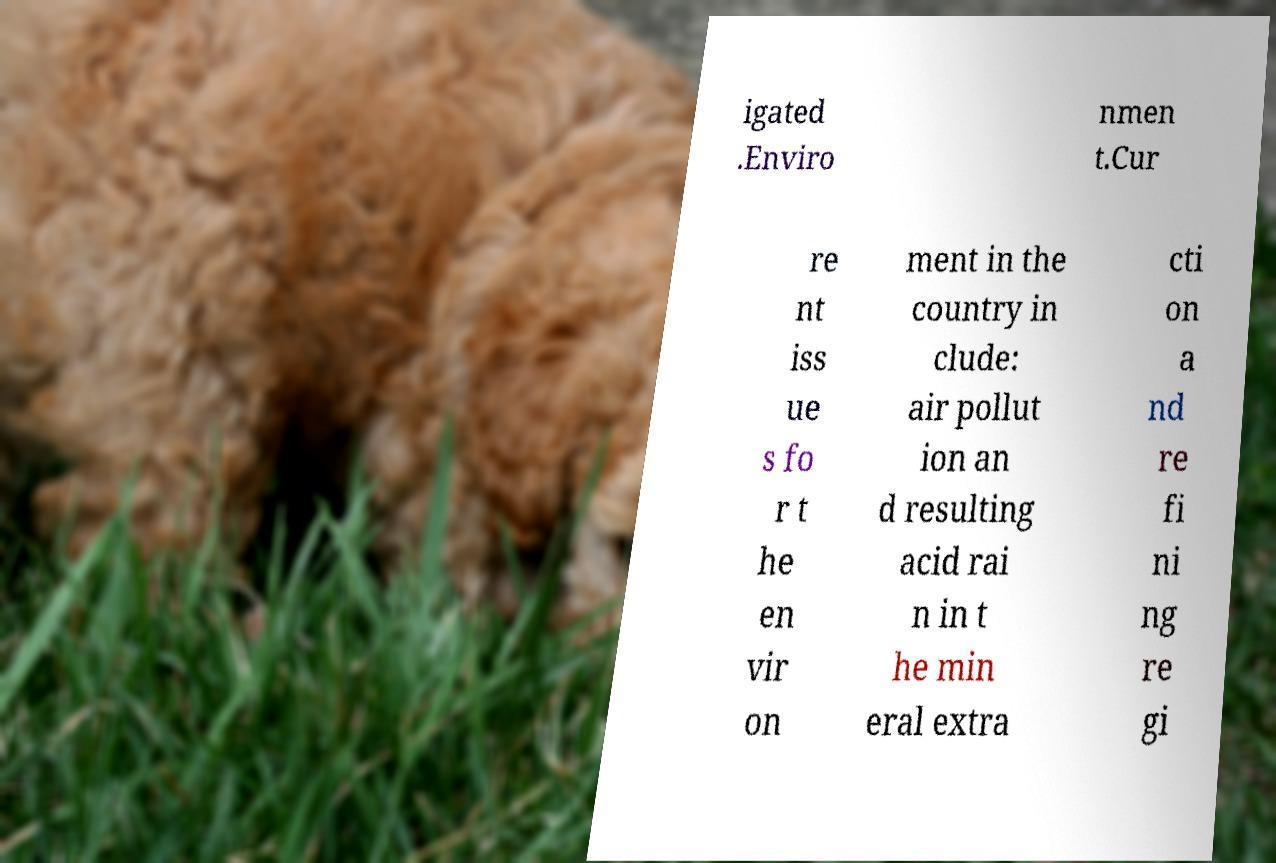Could you assist in decoding the text presented in this image and type it out clearly? igated .Enviro nmen t.Cur re nt iss ue s fo r t he en vir on ment in the country in clude: air pollut ion an d resulting acid rai n in t he min eral extra cti on a nd re fi ni ng re gi 